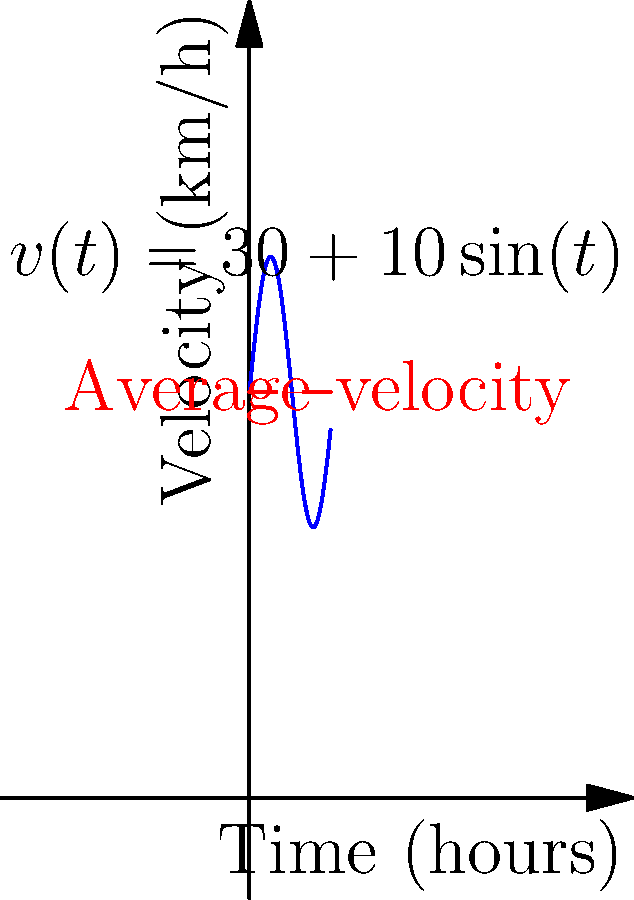A letter's velocity (in km/h) as it travels through the postal system is modeled by the function $v(t)=30+10\sin(t)$, where $t$ is time in hours. The red dashed line represents the average velocity. Calculate the total distance traveled by the letter over a 6-hour period. To find the total distance traveled, we need to calculate the area under the velocity-time curve. This is equivalent to integrating the velocity function over the given time interval.

1) The distance traveled is given by the definite integral:
   $$d = \int_0^6 v(t) dt = \int_0^6 (30+10\sin(t)) dt$$

2) Integrate the function:
   $$d = [30t - 10\cos(t)]_0^6$$

3) Evaluate the integral:
   $$d = (180 - 10\cos(6)) - (0 - 10\cos(0))$$
   $$d = 180 - 10\cos(6) + 10$$

4) Simplify:
   $$d = 190 - 10\cos(6)$$

5) Calculate the final value (rounded to two decimal places):
   $$d \approx 190 - 10(-0.96) \approx 199.60$$

Therefore, the letter travels approximately 199.60 km over the 6-hour period.
Answer: 199.60 km 